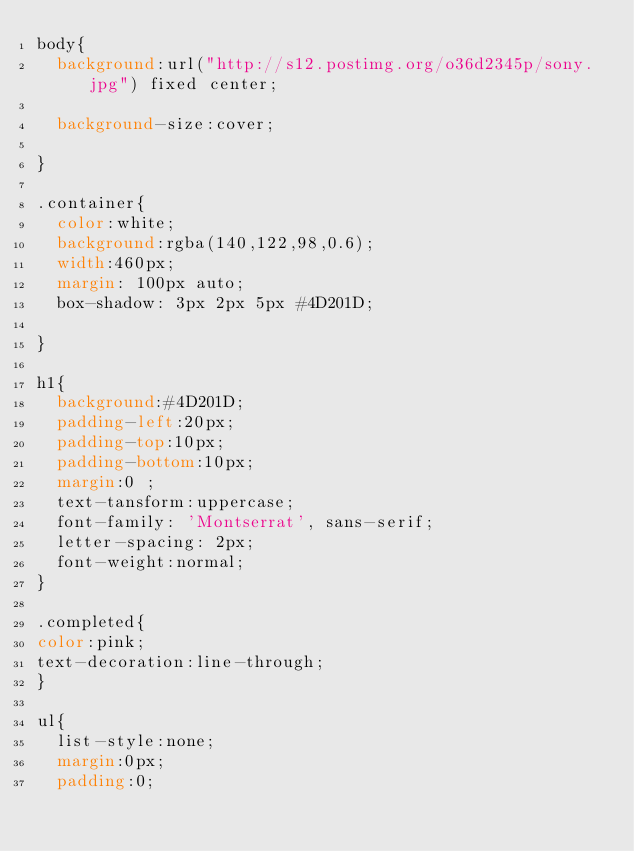<code> <loc_0><loc_0><loc_500><loc_500><_CSS_>body{
  background:url("http://s12.postimg.org/o36d2345p/sony.jpg") fixed center;
  
  background-size:cover;
  
}

.container{
  color:white;
  background:rgba(140,122,98,0.6);
  width:460px;
  margin: 100px auto;
  box-shadow: 3px 2px 5px #4D201D;
 
}

h1{
  background:#4D201D;
  padding-left:20px;
  padding-top:10px;
  padding-bottom:10px;
  margin:0 ;
  text-tansform:uppercase;
  font-family: 'Montserrat', sans-serif;  
  letter-spacing: 2px;
  font-weight:normal;
}

.completed{
color:pink;  
text-decoration:line-through;
}

ul{
  list-style:none;
  margin:0px;
  padding:0;</code> 